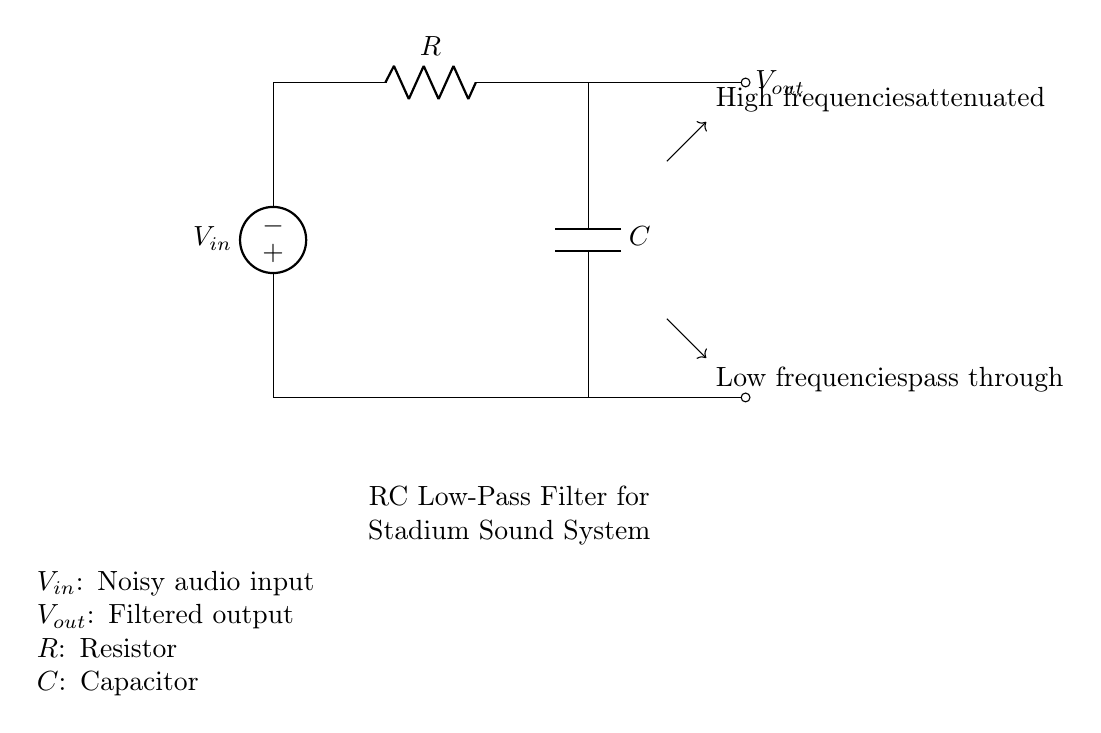What is the input voltage denoted as in the circuit? The input voltage is indicated by the symbol \( V_{in} \) located next to the voltage source in the circuit diagram.
Answer: \( V_{in} \) What component is used to filter the audio signal? The component that filters the audio signal in this circuit is the capacitor, noted as \( C \), which allows low frequencies to pass through while attenuating high frequencies.
Answer: Capacitor What is the role of the resistor in this RC filter? The resistor, denoted as \( R \), is crucial as it works together with the capacitor to form a low-pass filter, helping to set the cutoff frequency and controlling the rate at which the capacitor charges and discharges.
Answer: To set cutoff frequency What does the output voltage represent? The output voltage, noted as \( V_{out} \), represents the filtered audio signal that is produced after the noise reduction has occurred through the combination of the resistor and capacitor.
Answer: Filtered output Which frequencies are attenuated by this RC circuit? This RC filter is designed to attenuate high frequencies, which means that it reduces the amplitude of these frequencies to minimize noise in the audio output.
Answer: High frequencies What is a defining characteristic of a low-pass filter? A defining characteristic of a low-pass filter, such as this RC filter, is that it allows low-frequency signals to pass through while blocking higher frequencies. This is essential for reducing noise in sound systems by preserving clarity in the audio signal.
Answer: Allows low frequencies How does the combination of the resistor and capacitor determine the filter's performance? The combination of the resistor and capacitor determines the filter's performance through the time constant (τ), which is calculated by multiplying resistance (R) by capacitance (C). This time constant dictates how quickly the circuit responds to changes in input voltage, directly affecting the filter's cutoff frequency and behavior.
Answer: Through time constant 